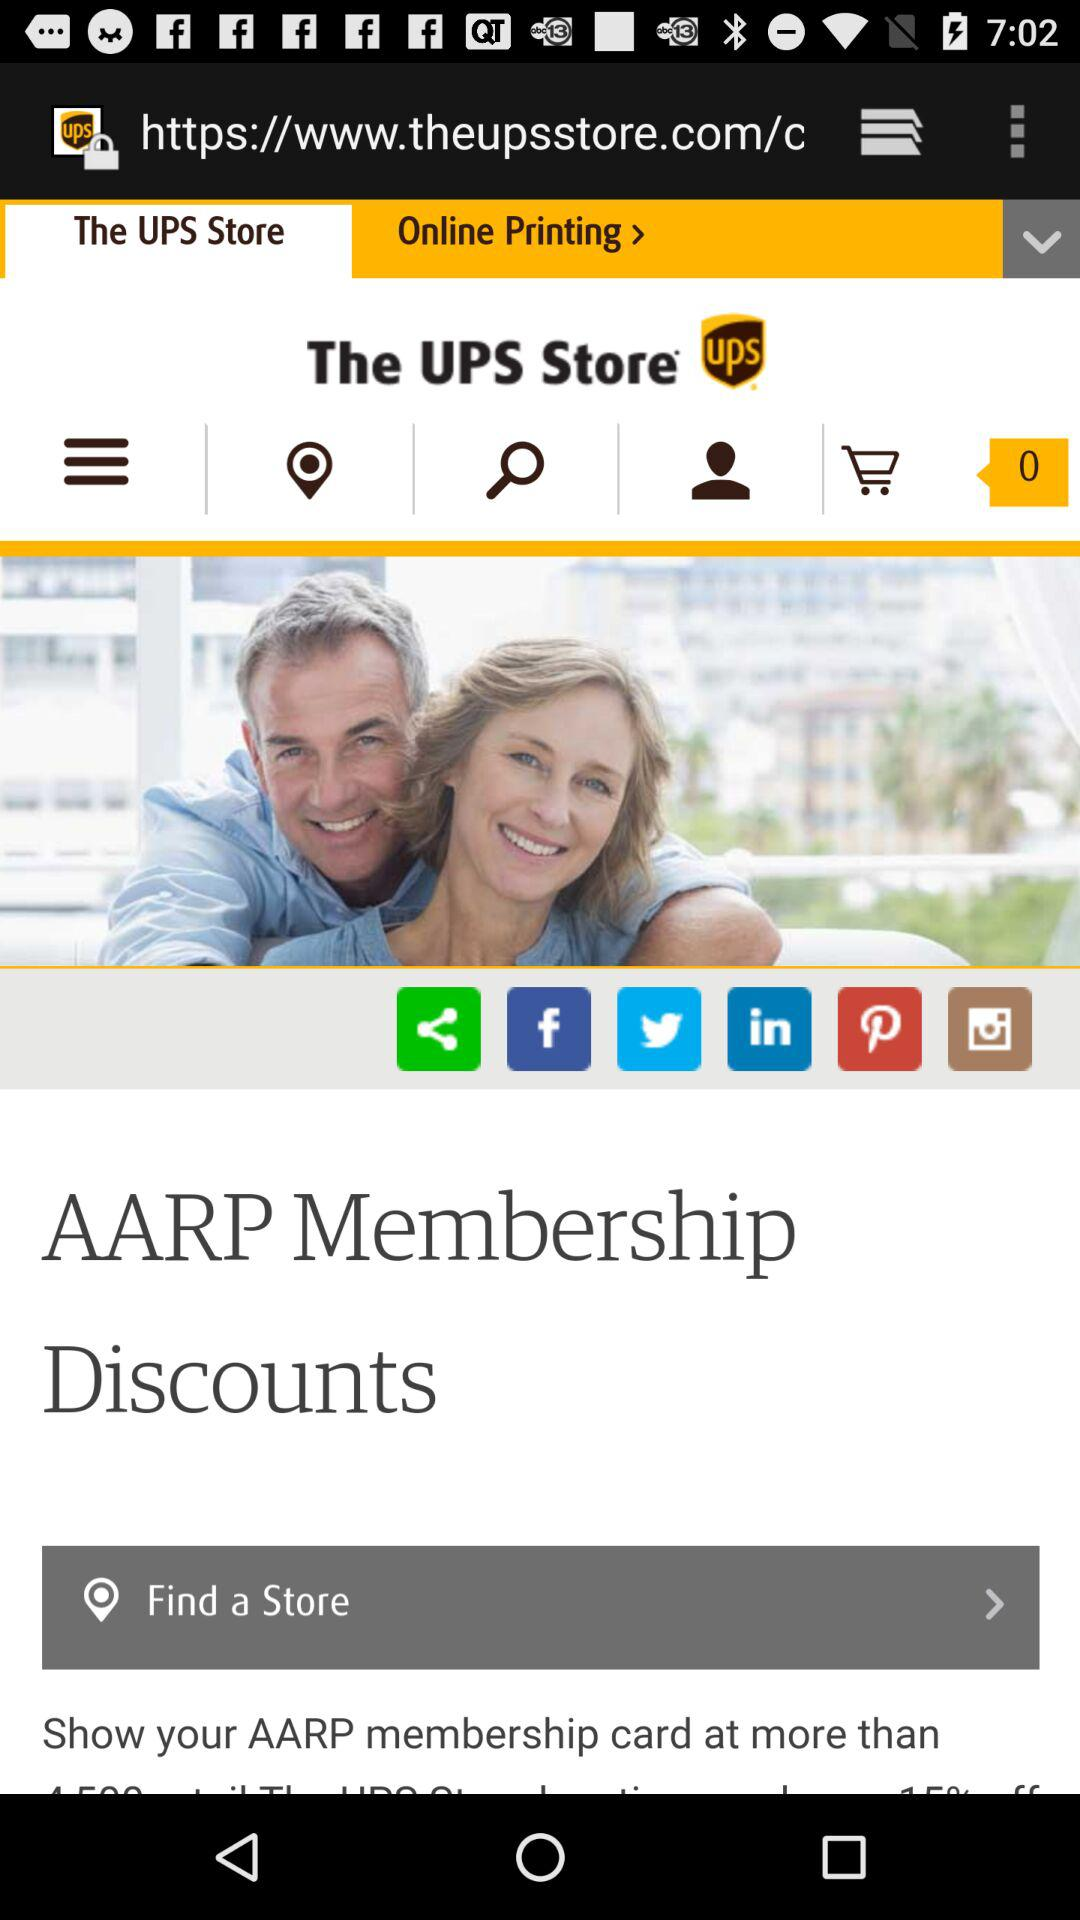Which tab has been selected? The tab that has been selected is "The UPS Store". 